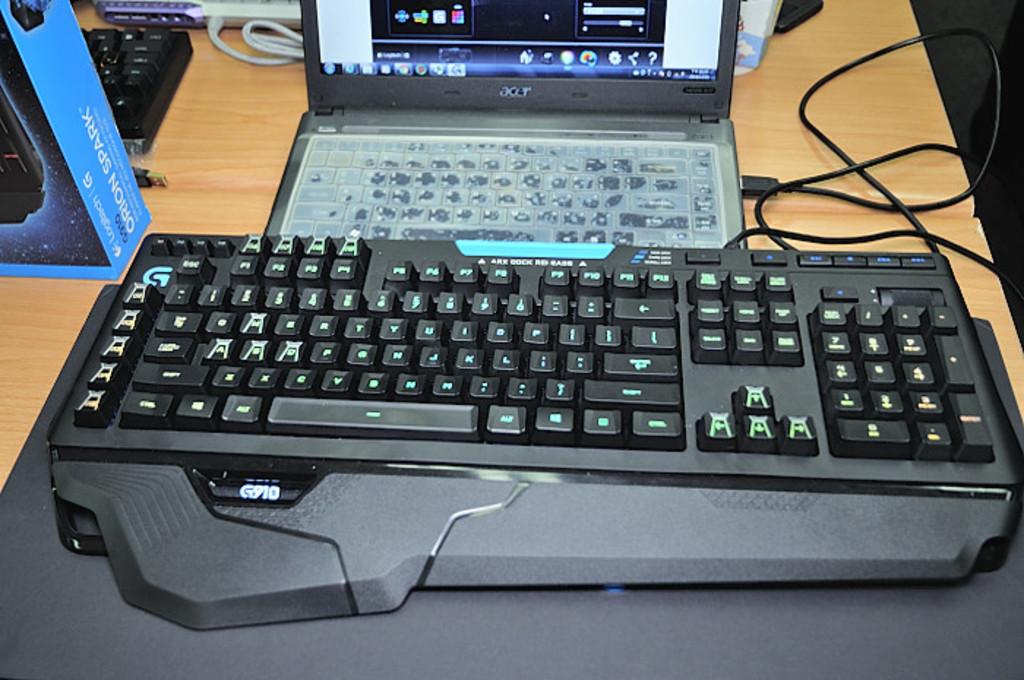What computer brand is that?
Keep it short and to the point. Acer. What brand of computer?
Your response must be concise. Acer. 